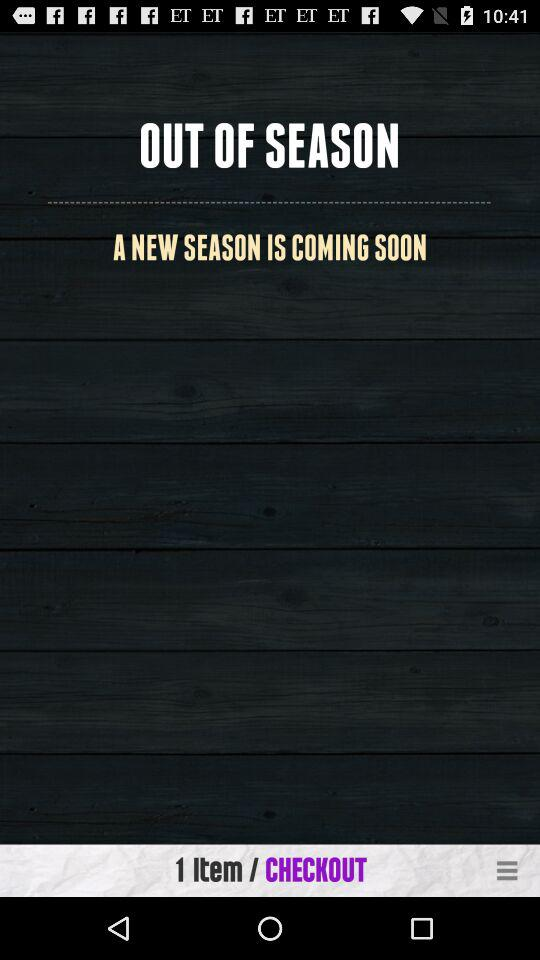How many items are there? There is 1 item. 